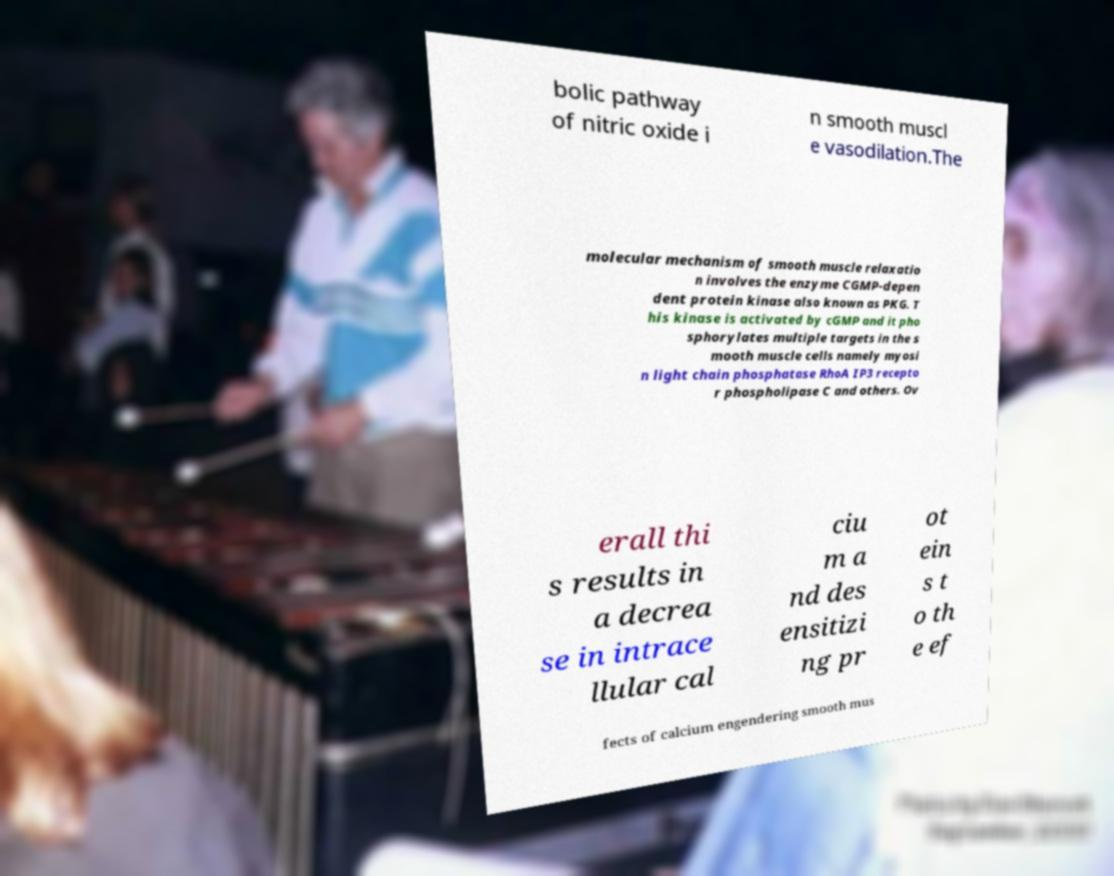For documentation purposes, I need the text within this image transcribed. Could you provide that? bolic pathway of nitric oxide i n smooth muscl e vasodilation.The molecular mechanism of smooth muscle relaxatio n involves the enzyme CGMP-depen dent protein kinase also known as PKG. T his kinase is activated by cGMP and it pho sphorylates multiple targets in the s mooth muscle cells namely myosi n light chain phosphatase RhoA IP3 recepto r phospholipase C and others. Ov erall thi s results in a decrea se in intrace llular cal ciu m a nd des ensitizi ng pr ot ein s t o th e ef fects of calcium engendering smooth mus 